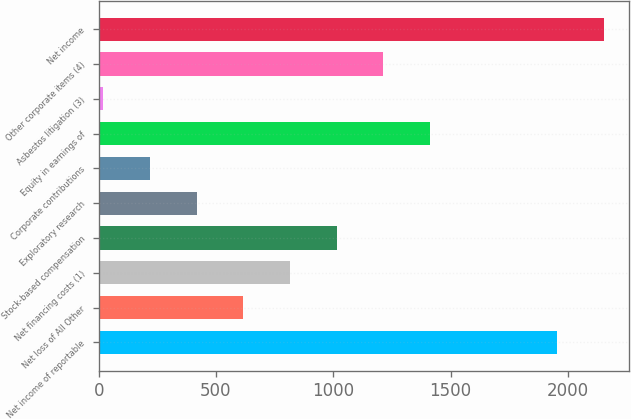<chart> <loc_0><loc_0><loc_500><loc_500><bar_chart><fcel>Net income of reportable<fcel>Net loss of All Other<fcel>Net financing costs (1)<fcel>Stock-based compensation<fcel>Exploratory research<fcel>Corporate contributions<fcel>Equity in earnings of<fcel>Asbestos litigation (3)<fcel>Other corporate items (4)<fcel>Net income<nl><fcel>1954<fcel>616.4<fcel>815.2<fcel>1014<fcel>417.6<fcel>218.8<fcel>1411.6<fcel>20<fcel>1212.8<fcel>2152.8<nl></chart> 